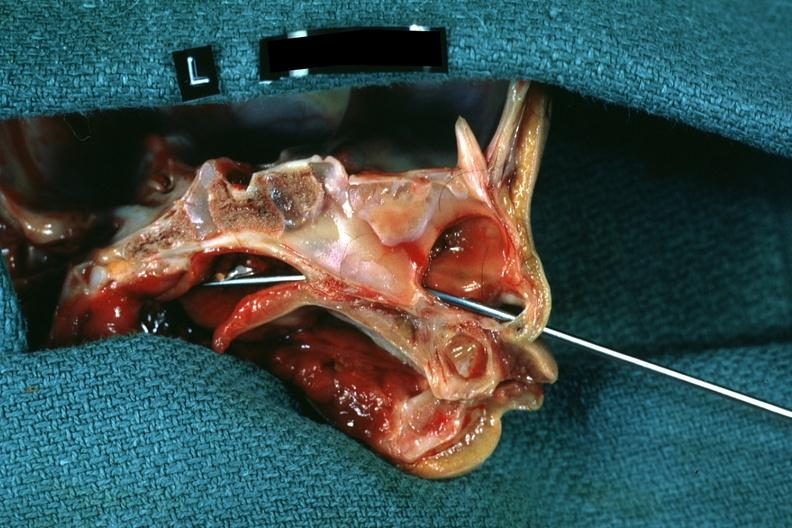how is hemisection of nose left side showing patency side was not patent?
Answer the question using a single word or phrase. Right 